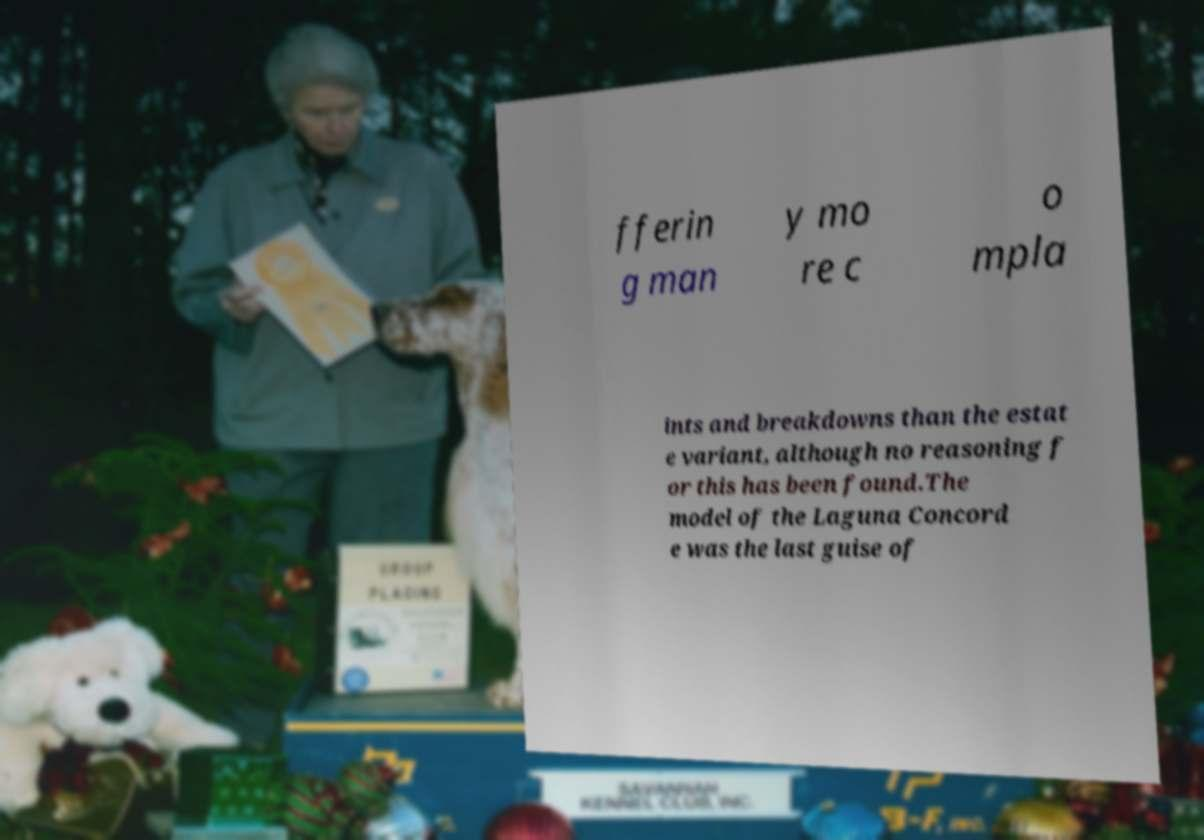I need the written content from this picture converted into text. Can you do that? fferin g man y mo re c o mpla ints and breakdowns than the estat e variant, although no reasoning f or this has been found.The model of the Laguna Concord e was the last guise of 